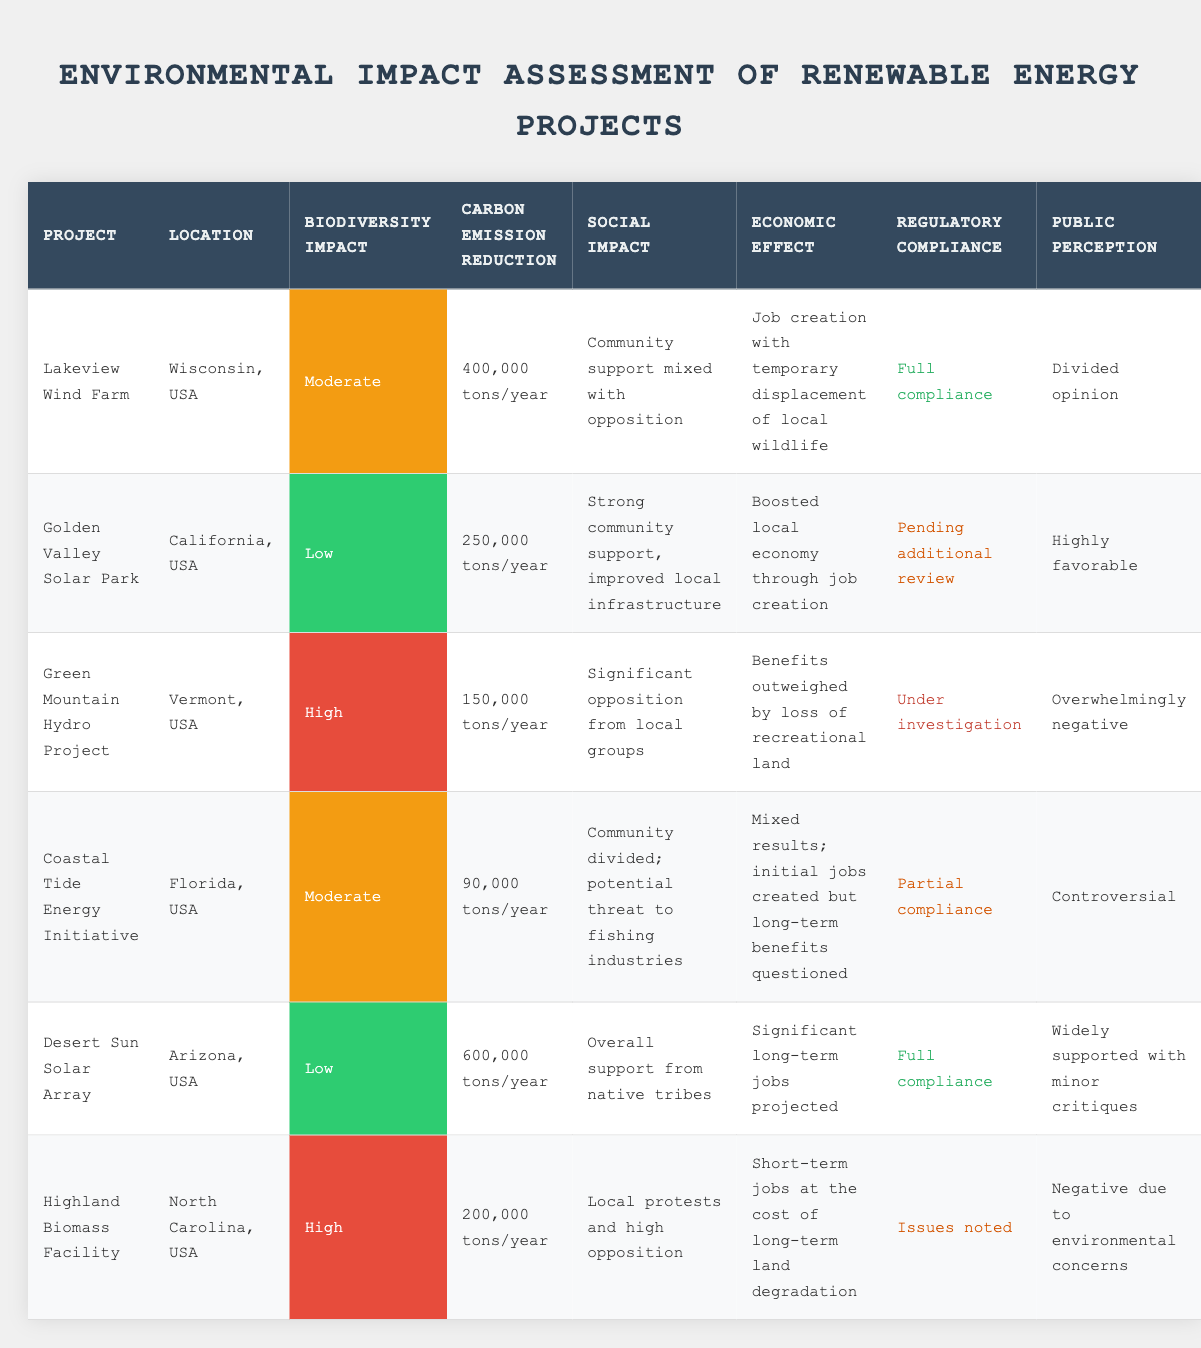What is the Carbon Emission Reduction for the Desert Sun Solar Array? The table indicates that the Desert Sun Solar Array has a Carbon Emission Reduction of 600,000 tons/year. This value is directly retrieved from the respective row in the table.
Answer: 600,000 tons/year Which project has the highest Biodiversity Impact? Looking through the Biodiversity Impact column, the Green Mountain Hydro Project has a Biodiversity Impact classified as High. This is the only entry marked as High, indicating it is the highest impact among the listed projects.
Answer: Green Mountain Hydro Project Is the Golden Valley Solar Park in full compliance with regulations? The table states that the Golden Valley Solar Park has a Regulatory Compliance status of Pending additional review. Since this does not indicate full compliance, the answer is no.
Answer: No How many projects have a moderate Biodiversity Impact? By examining the Biodiversity Impact column, two projects are classified as having a Moderate impact: Lakeview Wind Farm and Coastal Tide Energy Initiative. Therefore, there are a total of 2 projects.
Answer: 2 What is the average Carbon Emission Reduction of all projects? Calculating the Carbon Emission Reduction values from all projects: 400,000 + 250,000 + 150,000 + 90,000 + 600,000 + 200,000 = 1,690,000 tons/year. Since there are 6 projects, the average is 1,690,000 / 6 = 281,666.67 tons/year, which can be rounded to 281,667.
Answer: 281,667 tons/year Do any projects have overwhelming negative public perception? The table indicates that the Green Mountain Hydro Project has Public Perception described as Overwhelmingly negative. This qualifies as a yes to the question about whether any projects have such negative perception.
Answer: Yes What project had mixed results regarding its Economic Effect? The Coastal Tide Energy Initiative's Economic Effect is described as Mixed results; initial jobs created but long-term benefits questioned. This matches the criterion for mixed results regarding economic impact.
Answer: Coastal Tide Energy Initiative How many projects received full compliance? The projects with full compliance are Lakeview Wind Farm and Desert Sun Solar Array, making a total of 2 projects with this status.
Answer: 2 Which project has significant opposition from local groups? The Green Mountain Hydro Project is noted for having significant opposition from local groups in its Social Impact description, indicating it faces notable local resistance.
Answer: Green Mountain Hydro Project 